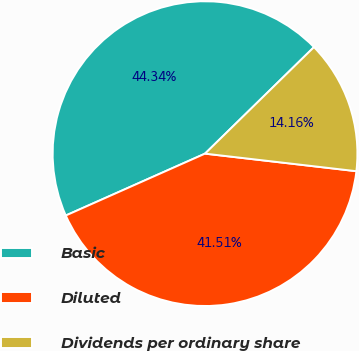<chart> <loc_0><loc_0><loc_500><loc_500><pie_chart><fcel>Basic<fcel>Diluted<fcel>Dividends per ordinary share<nl><fcel>44.34%<fcel>41.51%<fcel>14.16%<nl></chart> 